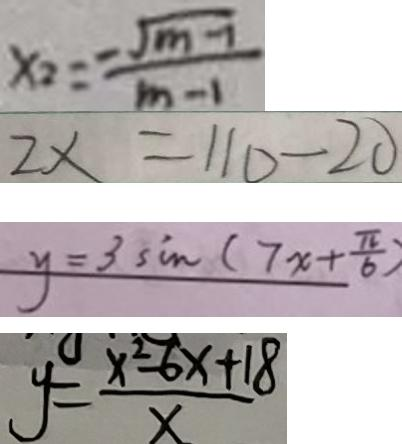Convert formula to latex. <formula><loc_0><loc_0><loc_500><loc_500>x _ { 2 } = \frac { - \sqrt { m - 1 } } { m - 1 } 
 2 \times = 1 1 0 - 2 0 
 y = 3 \sin ( 7 x + \frac { \pi } { 6 } ) 
 y = \frac { x ^ { 2 } - 6 x + 1 8 } { x }</formula> 